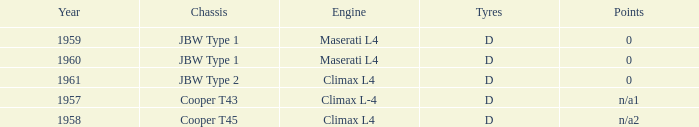What is the engine for a vehicle in 1960? Maserati L4. 